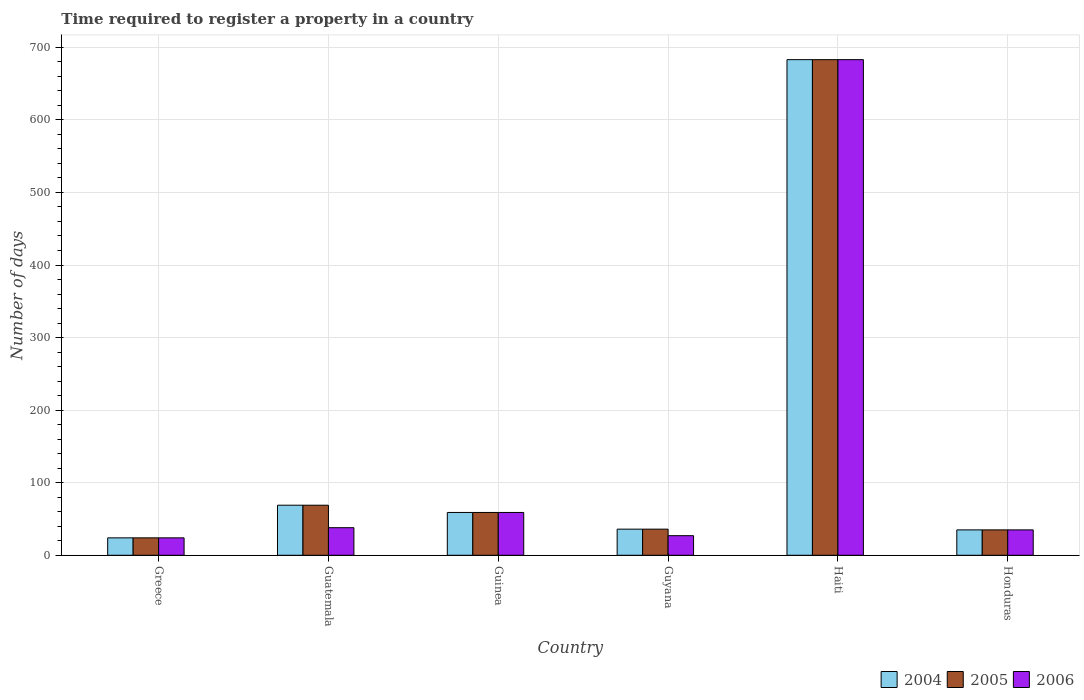How many different coloured bars are there?
Offer a terse response. 3. How many groups of bars are there?
Provide a succinct answer. 6. Are the number of bars per tick equal to the number of legend labels?
Your answer should be compact. Yes. Are the number of bars on each tick of the X-axis equal?
Keep it short and to the point. Yes. How many bars are there on the 5th tick from the right?
Give a very brief answer. 3. What is the label of the 3rd group of bars from the left?
Offer a terse response. Guinea. In how many cases, is the number of bars for a given country not equal to the number of legend labels?
Keep it short and to the point. 0. Across all countries, what is the maximum number of days required to register a property in 2004?
Your answer should be very brief. 683. In which country was the number of days required to register a property in 2005 maximum?
Your answer should be compact. Haiti. What is the total number of days required to register a property in 2005 in the graph?
Keep it short and to the point. 906. What is the difference between the number of days required to register a property in 2004 in Guatemala and the number of days required to register a property in 2005 in Guyana?
Give a very brief answer. 33. What is the average number of days required to register a property in 2004 per country?
Give a very brief answer. 151. What is the difference between the number of days required to register a property of/in 2006 and number of days required to register a property of/in 2004 in Guatemala?
Offer a very short reply. -31. In how many countries, is the number of days required to register a property in 2004 greater than 100 days?
Provide a short and direct response. 1. What is the ratio of the number of days required to register a property in 2006 in Guatemala to that in Guyana?
Offer a very short reply. 1.41. What is the difference between the highest and the second highest number of days required to register a property in 2005?
Provide a short and direct response. -624. What is the difference between the highest and the lowest number of days required to register a property in 2005?
Offer a terse response. 659. Is the sum of the number of days required to register a property in 2005 in Guatemala and Honduras greater than the maximum number of days required to register a property in 2006 across all countries?
Keep it short and to the point. No. How many countries are there in the graph?
Keep it short and to the point. 6. What is the difference between two consecutive major ticks on the Y-axis?
Your answer should be very brief. 100. Does the graph contain any zero values?
Your answer should be compact. No. Does the graph contain grids?
Keep it short and to the point. Yes. How many legend labels are there?
Provide a succinct answer. 3. What is the title of the graph?
Give a very brief answer. Time required to register a property in a country. Does "1962" appear as one of the legend labels in the graph?
Keep it short and to the point. No. What is the label or title of the Y-axis?
Provide a succinct answer. Number of days. What is the Number of days of 2006 in Greece?
Provide a succinct answer. 24. What is the Number of days in 2004 in Guatemala?
Offer a very short reply. 69. What is the Number of days of 2005 in Guatemala?
Your answer should be compact. 69. What is the Number of days in 2004 in Guyana?
Offer a very short reply. 36. What is the Number of days of 2005 in Guyana?
Your answer should be compact. 36. What is the Number of days in 2004 in Haiti?
Offer a very short reply. 683. What is the Number of days of 2005 in Haiti?
Ensure brevity in your answer.  683. What is the Number of days of 2006 in Haiti?
Provide a succinct answer. 683. What is the Number of days in 2005 in Honduras?
Your answer should be compact. 35. What is the Number of days in 2006 in Honduras?
Your answer should be compact. 35. Across all countries, what is the maximum Number of days in 2004?
Make the answer very short. 683. Across all countries, what is the maximum Number of days in 2005?
Your response must be concise. 683. Across all countries, what is the maximum Number of days in 2006?
Your answer should be very brief. 683. Across all countries, what is the minimum Number of days in 2005?
Make the answer very short. 24. What is the total Number of days in 2004 in the graph?
Give a very brief answer. 906. What is the total Number of days of 2005 in the graph?
Offer a very short reply. 906. What is the total Number of days in 2006 in the graph?
Give a very brief answer. 866. What is the difference between the Number of days of 2004 in Greece and that in Guatemala?
Provide a short and direct response. -45. What is the difference between the Number of days of 2005 in Greece and that in Guatemala?
Make the answer very short. -45. What is the difference between the Number of days in 2004 in Greece and that in Guinea?
Provide a short and direct response. -35. What is the difference between the Number of days of 2005 in Greece and that in Guinea?
Ensure brevity in your answer.  -35. What is the difference between the Number of days in 2006 in Greece and that in Guinea?
Give a very brief answer. -35. What is the difference between the Number of days of 2006 in Greece and that in Guyana?
Your answer should be compact. -3. What is the difference between the Number of days in 2004 in Greece and that in Haiti?
Provide a succinct answer. -659. What is the difference between the Number of days in 2005 in Greece and that in Haiti?
Your answer should be very brief. -659. What is the difference between the Number of days in 2006 in Greece and that in Haiti?
Offer a terse response. -659. What is the difference between the Number of days in 2004 in Greece and that in Honduras?
Give a very brief answer. -11. What is the difference between the Number of days of 2005 in Greece and that in Honduras?
Make the answer very short. -11. What is the difference between the Number of days in 2004 in Guatemala and that in Guyana?
Ensure brevity in your answer.  33. What is the difference between the Number of days in 2005 in Guatemala and that in Guyana?
Ensure brevity in your answer.  33. What is the difference between the Number of days in 2006 in Guatemala and that in Guyana?
Provide a short and direct response. 11. What is the difference between the Number of days of 2004 in Guatemala and that in Haiti?
Your answer should be compact. -614. What is the difference between the Number of days in 2005 in Guatemala and that in Haiti?
Provide a short and direct response. -614. What is the difference between the Number of days of 2006 in Guatemala and that in Haiti?
Ensure brevity in your answer.  -645. What is the difference between the Number of days in 2004 in Guatemala and that in Honduras?
Offer a very short reply. 34. What is the difference between the Number of days of 2005 in Guatemala and that in Honduras?
Provide a short and direct response. 34. What is the difference between the Number of days of 2006 in Guatemala and that in Honduras?
Your answer should be compact. 3. What is the difference between the Number of days of 2005 in Guinea and that in Guyana?
Offer a terse response. 23. What is the difference between the Number of days of 2004 in Guinea and that in Haiti?
Provide a short and direct response. -624. What is the difference between the Number of days of 2005 in Guinea and that in Haiti?
Make the answer very short. -624. What is the difference between the Number of days of 2006 in Guinea and that in Haiti?
Provide a short and direct response. -624. What is the difference between the Number of days in 2004 in Guinea and that in Honduras?
Your answer should be compact. 24. What is the difference between the Number of days of 2005 in Guinea and that in Honduras?
Your answer should be compact. 24. What is the difference between the Number of days in 2004 in Guyana and that in Haiti?
Keep it short and to the point. -647. What is the difference between the Number of days of 2005 in Guyana and that in Haiti?
Ensure brevity in your answer.  -647. What is the difference between the Number of days in 2006 in Guyana and that in Haiti?
Provide a succinct answer. -656. What is the difference between the Number of days of 2004 in Guyana and that in Honduras?
Your answer should be compact. 1. What is the difference between the Number of days of 2006 in Guyana and that in Honduras?
Provide a succinct answer. -8. What is the difference between the Number of days of 2004 in Haiti and that in Honduras?
Ensure brevity in your answer.  648. What is the difference between the Number of days of 2005 in Haiti and that in Honduras?
Your answer should be compact. 648. What is the difference between the Number of days in 2006 in Haiti and that in Honduras?
Your answer should be compact. 648. What is the difference between the Number of days in 2004 in Greece and the Number of days in 2005 in Guatemala?
Provide a short and direct response. -45. What is the difference between the Number of days in 2004 in Greece and the Number of days in 2006 in Guatemala?
Offer a terse response. -14. What is the difference between the Number of days of 2005 in Greece and the Number of days of 2006 in Guatemala?
Offer a terse response. -14. What is the difference between the Number of days of 2004 in Greece and the Number of days of 2005 in Guinea?
Offer a very short reply. -35. What is the difference between the Number of days in 2004 in Greece and the Number of days in 2006 in Guinea?
Your answer should be compact. -35. What is the difference between the Number of days in 2005 in Greece and the Number of days in 2006 in Guinea?
Make the answer very short. -35. What is the difference between the Number of days of 2005 in Greece and the Number of days of 2006 in Guyana?
Make the answer very short. -3. What is the difference between the Number of days in 2004 in Greece and the Number of days in 2005 in Haiti?
Your answer should be compact. -659. What is the difference between the Number of days of 2004 in Greece and the Number of days of 2006 in Haiti?
Give a very brief answer. -659. What is the difference between the Number of days of 2005 in Greece and the Number of days of 2006 in Haiti?
Offer a terse response. -659. What is the difference between the Number of days of 2005 in Greece and the Number of days of 2006 in Honduras?
Provide a succinct answer. -11. What is the difference between the Number of days of 2005 in Guatemala and the Number of days of 2006 in Guinea?
Your response must be concise. 10. What is the difference between the Number of days of 2004 in Guatemala and the Number of days of 2006 in Guyana?
Keep it short and to the point. 42. What is the difference between the Number of days of 2004 in Guatemala and the Number of days of 2005 in Haiti?
Your response must be concise. -614. What is the difference between the Number of days in 2004 in Guatemala and the Number of days in 2006 in Haiti?
Provide a short and direct response. -614. What is the difference between the Number of days in 2005 in Guatemala and the Number of days in 2006 in Haiti?
Give a very brief answer. -614. What is the difference between the Number of days in 2004 in Guinea and the Number of days in 2006 in Guyana?
Offer a terse response. 32. What is the difference between the Number of days in 2005 in Guinea and the Number of days in 2006 in Guyana?
Your answer should be compact. 32. What is the difference between the Number of days of 2004 in Guinea and the Number of days of 2005 in Haiti?
Keep it short and to the point. -624. What is the difference between the Number of days of 2004 in Guinea and the Number of days of 2006 in Haiti?
Offer a terse response. -624. What is the difference between the Number of days in 2005 in Guinea and the Number of days in 2006 in Haiti?
Provide a short and direct response. -624. What is the difference between the Number of days in 2004 in Guyana and the Number of days in 2005 in Haiti?
Your answer should be very brief. -647. What is the difference between the Number of days in 2004 in Guyana and the Number of days in 2006 in Haiti?
Offer a terse response. -647. What is the difference between the Number of days in 2005 in Guyana and the Number of days in 2006 in Haiti?
Give a very brief answer. -647. What is the difference between the Number of days of 2004 in Guyana and the Number of days of 2005 in Honduras?
Offer a very short reply. 1. What is the difference between the Number of days of 2004 in Haiti and the Number of days of 2005 in Honduras?
Provide a short and direct response. 648. What is the difference between the Number of days in 2004 in Haiti and the Number of days in 2006 in Honduras?
Make the answer very short. 648. What is the difference between the Number of days of 2005 in Haiti and the Number of days of 2006 in Honduras?
Keep it short and to the point. 648. What is the average Number of days of 2004 per country?
Give a very brief answer. 151. What is the average Number of days in 2005 per country?
Keep it short and to the point. 151. What is the average Number of days of 2006 per country?
Provide a short and direct response. 144.33. What is the difference between the Number of days of 2004 and Number of days of 2005 in Greece?
Offer a terse response. 0. What is the difference between the Number of days of 2005 and Number of days of 2006 in Greece?
Offer a terse response. 0. What is the difference between the Number of days in 2004 and Number of days in 2005 in Guatemala?
Keep it short and to the point. 0. What is the difference between the Number of days of 2004 and Number of days of 2006 in Guatemala?
Ensure brevity in your answer.  31. What is the difference between the Number of days of 2004 and Number of days of 2005 in Guyana?
Ensure brevity in your answer.  0. What is the difference between the Number of days in 2004 and Number of days in 2006 in Haiti?
Your response must be concise. 0. What is the difference between the Number of days of 2005 and Number of days of 2006 in Haiti?
Give a very brief answer. 0. What is the ratio of the Number of days of 2004 in Greece to that in Guatemala?
Provide a short and direct response. 0.35. What is the ratio of the Number of days in 2005 in Greece to that in Guatemala?
Ensure brevity in your answer.  0.35. What is the ratio of the Number of days in 2006 in Greece to that in Guatemala?
Provide a succinct answer. 0.63. What is the ratio of the Number of days in 2004 in Greece to that in Guinea?
Your answer should be very brief. 0.41. What is the ratio of the Number of days of 2005 in Greece to that in Guinea?
Offer a terse response. 0.41. What is the ratio of the Number of days in 2006 in Greece to that in Guinea?
Keep it short and to the point. 0.41. What is the ratio of the Number of days of 2004 in Greece to that in Guyana?
Your answer should be compact. 0.67. What is the ratio of the Number of days in 2006 in Greece to that in Guyana?
Keep it short and to the point. 0.89. What is the ratio of the Number of days in 2004 in Greece to that in Haiti?
Give a very brief answer. 0.04. What is the ratio of the Number of days in 2005 in Greece to that in Haiti?
Offer a terse response. 0.04. What is the ratio of the Number of days of 2006 in Greece to that in Haiti?
Offer a very short reply. 0.04. What is the ratio of the Number of days in 2004 in Greece to that in Honduras?
Offer a very short reply. 0.69. What is the ratio of the Number of days in 2005 in Greece to that in Honduras?
Offer a terse response. 0.69. What is the ratio of the Number of days of 2006 in Greece to that in Honduras?
Offer a terse response. 0.69. What is the ratio of the Number of days in 2004 in Guatemala to that in Guinea?
Keep it short and to the point. 1.17. What is the ratio of the Number of days in 2005 in Guatemala to that in Guinea?
Ensure brevity in your answer.  1.17. What is the ratio of the Number of days of 2006 in Guatemala to that in Guinea?
Your response must be concise. 0.64. What is the ratio of the Number of days in 2004 in Guatemala to that in Guyana?
Ensure brevity in your answer.  1.92. What is the ratio of the Number of days in 2005 in Guatemala to that in Guyana?
Your response must be concise. 1.92. What is the ratio of the Number of days of 2006 in Guatemala to that in Guyana?
Your answer should be very brief. 1.41. What is the ratio of the Number of days in 2004 in Guatemala to that in Haiti?
Provide a succinct answer. 0.1. What is the ratio of the Number of days of 2005 in Guatemala to that in Haiti?
Make the answer very short. 0.1. What is the ratio of the Number of days in 2006 in Guatemala to that in Haiti?
Offer a very short reply. 0.06. What is the ratio of the Number of days of 2004 in Guatemala to that in Honduras?
Offer a very short reply. 1.97. What is the ratio of the Number of days in 2005 in Guatemala to that in Honduras?
Offer a terse response. 1.97. What is the ratio of the Number of days of 2006 in Guatemala to that in Honduras?
Your answer should be very brief. 1.09. What is the ratio of the Number of days of 2004 in Guinea to that in Guyana?
Offer a very short reply. 1.64. What is the ratio of the Number of days of 2005 in Guinea to that in Guyana?
Make the answer very short. 1.64. What is the ratio of the Number of days in 2006 in Guinea to that in Guyana?
Provide a succinct answer. 2.19. What is the ratio of the Number of days of 2004 in Guinea to that in Haiti?
Offer a terse response. 0.09. What is the ratio of the Number of days of 2005 in Guinea to that in Haiti?
Provide a short and direct response. 0.09. What is the ratio of the Number of days in 2006 in Guinea to that in Haiti?
Your response must be concise. 0.09. What is the ratio of the Number of days of 2004 in Guinea to that in Honduras?
Offer a terse response. 1.69. What is the ratio of the Number of days in 2005 in Guinea to that in Honduras?
Your answer should be very brief. 1.69. What is the ratio of the Number of days of 2006 in Guinea to that in Honduras?
Ensure brevity in your answer.  1.69. What is the ratio of the Number of days in 2004 in Guyana to that in Haiti?
Offer a very short reply. 0.05. What is the ratio of the Number of days of 2005 in Guyana to that in Haiti?
Ensure brevity in your answer.  0.05. What is the ratio of the Number of days of 2006 in Guyana to that in Haiti?
Give a very brief answer. 0.04. What is the ratio of the Number of days in 2004 in Guyana to that in Honduras?
Offer a terse response. 1.03. What is the ratio of the Number of days of 2005 in Guyana to that in Honduras?
Give a very brief answer. 1.03. What is the ratio of the Number of days of 2006 in Guyana to that in Honduras?
Keep it short and to the point. 0.77. What is the ratio of the Number of days in 2004 in Haiti to that in Honduras?
Your response must be concise. 19.51. What is the ratio of the Number of days of 2005 in Haiti to that in Honduras?
Provide a succinct answer. 19.51. What is the ratio of the Number of days of 2006 in Haiti to that in Honduras?
Provide a succinct answer. 19.51. What is the difference between the highest and the second highest Number of days of 2004?
Give a very brief answer. 614. What is the difference between the highest and the second highest Number of days of 2005?
Your answer should be compact. 614. What is the difference between the highest and the second highest Number of days in 2006?
Ensure brevity in your answer.  624. What is the difference between the highest and the lowest Number of days in 2004?
Keep it short and to the point. 659. What is the difference between the highest and the lowest Number of days in 2005?
Offer a very short reply. 659. What is the difference between the highest and the lowest Number of days in 2006?
Keep it short and to the point. 659. 